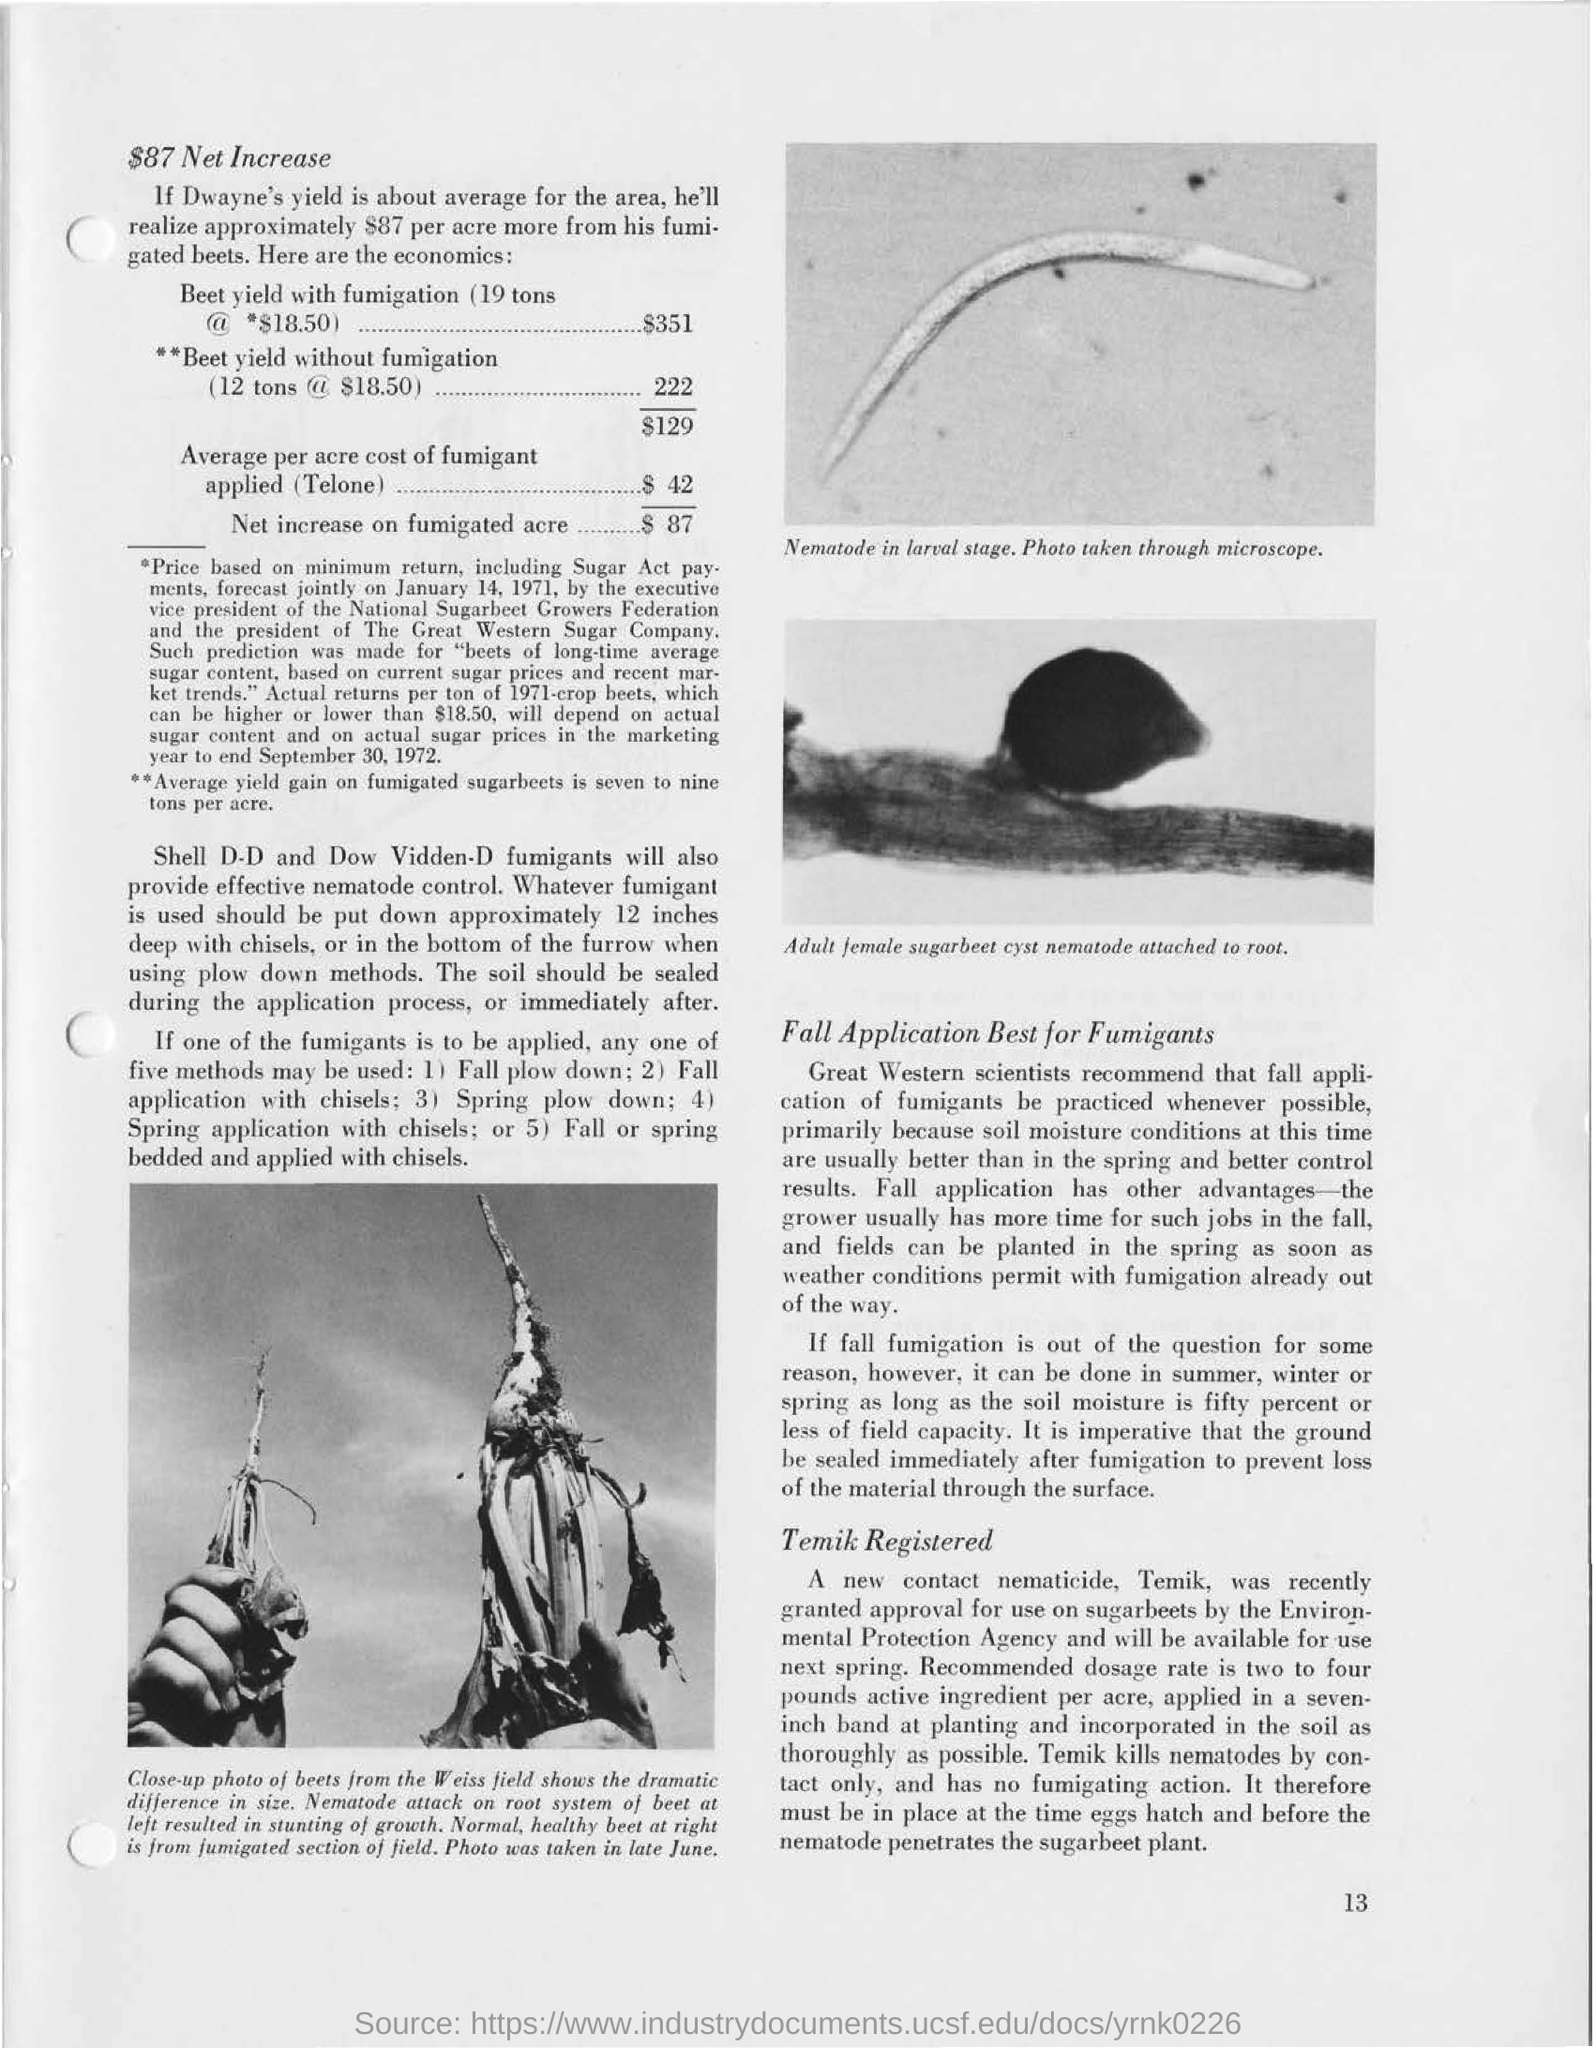What does the image in the top right depict?
Make the answer very short. Nematode in larval stage. What is the average per acre cost of fumigant applied (telone)?
Give a very brief answer. $42. 